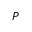Convert formula to latex. <formula><loc_0><loc_0><loc_500><loc_500>\bar { P }</formula> 